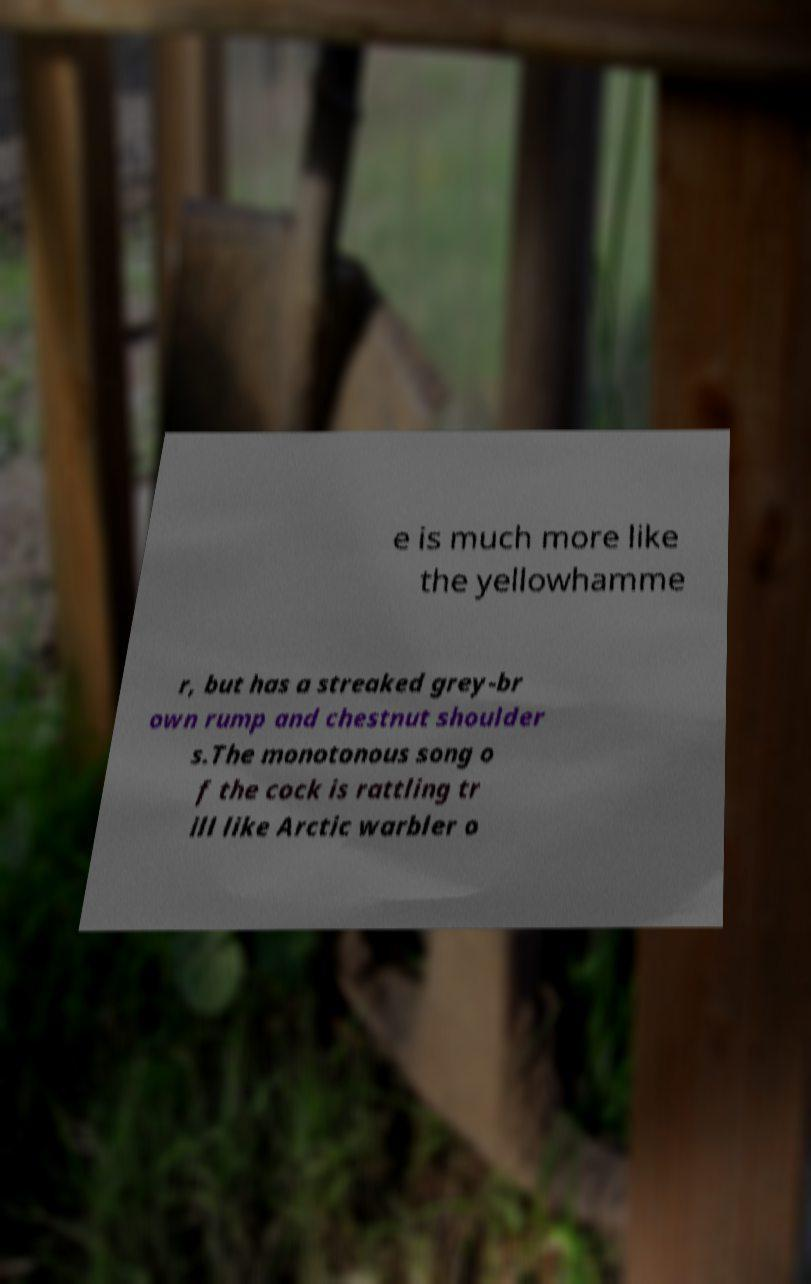I need the written content from this picture converted into text. Can you do that? e is much more like the yellowhamme r, but has a streaked grey-br own rump and chestnut shoulder s.The monotonous song o f the cock is rattling tr ill like Arctic warbler o 